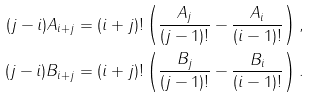Convert formula to latex. <formula><loc_0><loc_0><loc_500><loc_500>( j - i ) A _ { i + j } & = ( i + j ) ! \left ( \frac { A _ { j } } { ( j - 1 ) ! } - \frac { A _ { i } } { ( i - 1 ) ! } \right ) , \\ ( j - i ) B _ { i + j } & = ( i + j ) ! \left ( \frac { B _ { j } } { ( j - 1 ) ! } - \frac { B _ { i } } { ( i - 1 ) ! } \right ) .</formula> 